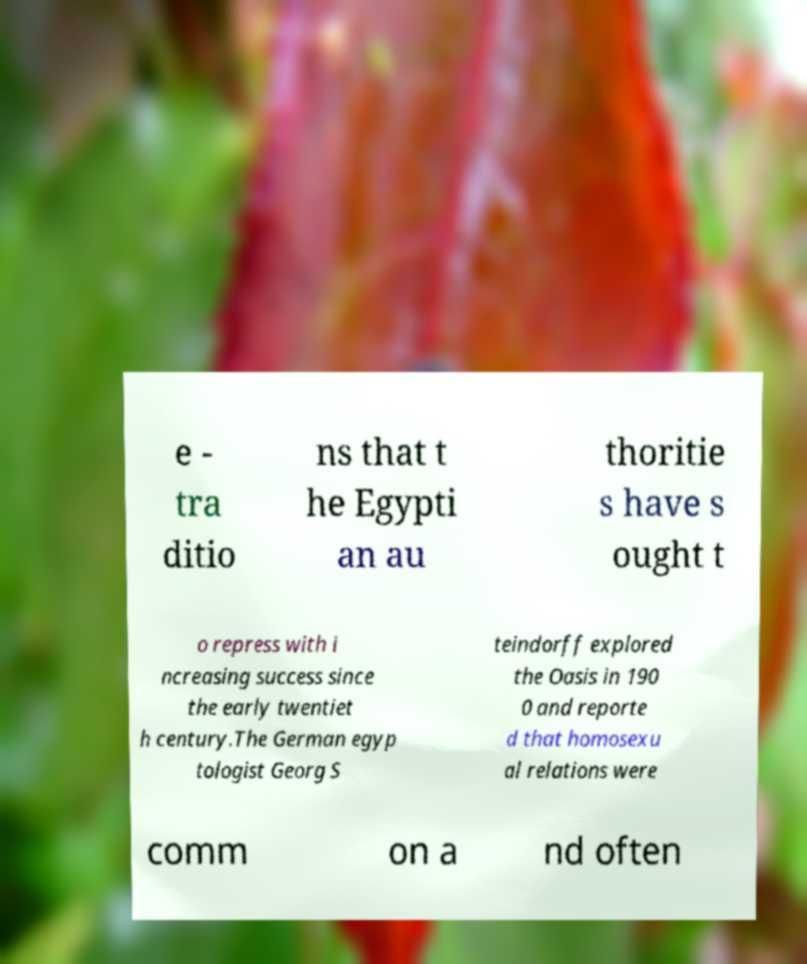For documentation purposes, I need the text within this image transcribed. Could you provide that? e - tra ditio ns that t he Egypti an au thoritie s have s ought t o repress with i ncreasing success since the early twentiet h century.The German egyp tologist Georg S teindorff explored the Oasis in 190 0 and reporte d that homosexu al relations were comm on a nd often 